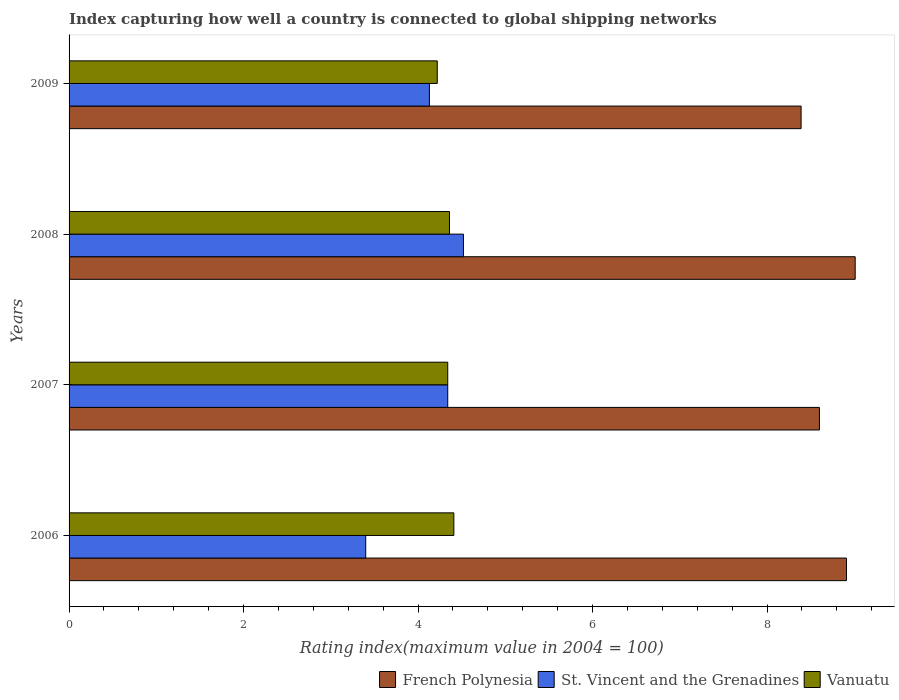How many different coloured bars are there?
Provide a short and direct response. 3. How many groups of bars are there?
Make the answer very short. 4. How many bars are there on the 3rd tick from the top?
Provide a succinct answer. 3. What is the label of the 2nd group of bars from the top?
Ensure brevity in your answer.  2008. What is the rating index in St. Vincent and the Grenadines in 2006?
Your response must be concise. 3.4. Across all years, what is the maximum rating index in St. Vincent and the Grenadines?
Offer a very short reply. 4.52. Across all years, what is the minimum rating index in French Polynesia?
Keep it short and to the point. 8.39. In which year was the rating index in St. Vincent and the Grenadines maximum?
Your response must be concise. 2008. In which year was the rating index in Vanuatu minimum?
Your answer should be very brief. 2009. What is the total rating index in Vanuatu in the graph?
Provide a succinct answer. 17.33. What is the difference between the rating index in Vanuatu in 2007 and that in 2009?
Your response must be concise. 0.12. What is the difference between the rating index in Vanuatu in 2006 and the rating index in St. Vincent and the Grenadines in 2008?
Make the answer very short. -0.11. What is the average rating index in St. Vincent and the Grenadines per year?
Ensure brevity in your answer.  4.1. In the year 2008, what is the difference between the rating index in French Polynesia and rating index in Vanuatu?
Keep it short and to the point. 4.65. In how many years, is the rating index in French Polynesia greater than 6 ?
Your response must be concise. 4. What is the ratio of the rating index in French Polynesia in 2008 to that in 2009?
Offer a terse response. 1.07. Is the difference between the rating index in French Polynesia in 2007 and 2008 greater than the difference between the rating index in Vanuatu in 2007 and 2008?
Provide a succinct answer. No. What is the difference between the highest and the second highest rating index in French Polynesia?
Your response must be concise. 0.1. What is the difference between the highest and the lowest rating index in Vanuatu?
Offer a very short reply. 0.19. What does the 3rd bar from the top in 2006 represents?
Ensure brevity in your answer.  French Polynesia. What does the 1st bar from the bottom in 2007 represents?
Make the answer very short. French Polynesia. Is it the case that in every year, the sum of the rating index in Vanuatu and rating index in St. Vincent and the Grenadines is greater than the rating index in French Polynesia?
Offer a terse response. No. How many bars are there?
Your response must be concise. 12. Are the values on the major ticks of X-axis written in scientific E-notation?
Offer a terse response. No. Does the graph contain any zero values?
Ensure brevity in your answer.  No. Does the graph contain grids?
Ensure brevity in your answer.  No. How are the legend labels stacked?
Your response must be concise. Horizontal. What is the title of the graph?
Your answer should be very brief. Index capturing how well a country is connected to global shipping networks. What is the label or title of the X-axis?
Your response must be concise. Rating index(maximum value in 2004 = 100). What is the Rating index(maximum value in 2004 = 100) of French Polynesia in 2006?
Provide a short and direct response. 8.91. What is the Rating index(maximum value in 2004 = 100) in St. Vincent and the Grenadines in 2006?
Your answer should be compact. 3.4. What is the Rating index(maximum value in 2004 = 100) of Vanuatu in 2006?
Make the answer very short. 4.41. What is the Rating index(maximum value in 2004 = 100) in French Polynesia in 2007?
Your answer should be very brief. 8.6. What is the Rating index(maximum value in 2004 = 100) of St. Vincent and the Grenadines in 2007?
Give a very brief answer. 4.34. What is the Rating index(maximum value in 2004 = 100) of Vanuatu in 2007?
Provide a short and direct response. 4.34. What is the Rating index(maximum value in 2004 = 100) in French Polynesia in 2008?
Your response must be concise. 9.01. What is the Rating index(maximum value in 2004 = 100) of St. Vincent and the Grenadines in 2008?
Provide a succinct answer. 4.52. What is the Rating index(maximum value in 2004 = 100) in Vanuatu in 2008?
Keep it short and to the point. 4.36. What is the Rating index(maximum value in 2004 = 100) in French Polynesia in 2009?
Your answer should be very brief. 8.39. What is the Rating index(maximum value in 2004 = 100) in St. Vincent and the Grenadines in 2009?
Offer a very short reply. 4.13. What is the Rating index(maximum value in 2004 = 100) of Vanuatu in 2009?
Offer a very short reply. 4.22. Across all years, what is the maximum Rating index(maximum value in 2004 = 100) in French Polynesia?
Provide a short and direct response. 9.01. Across all years, what is the maximum Rating index(maximum value in 2004 = 100) in St. Vincent and the Grenadines?
Your answer should be compact. 4.52. Across all years, what is the maximum Rating index(maximum value in 2004 = 100) in Vanuatu?
Your answer should be very brief. 4.41. Across all years, what is the minimum Rating index(maximum value in 2004 = 100) in French Polynesia?
Your response must be concise. 8.39. Across all years, what is the minimum Rating index(maximum value in 2004 = 100) in Vanuatu?
Give a very brief answer. 4.22. What is the total Rating index(maximum value in 2004 = 100) in French Polynesia in the graph?
Provide a succinct answer. 34.91. What is the total Rating index(maximum value in 2004 = 100) of St. Vincent and the Grenadines in the graph?
Offer a very short reply. 16.39. What is the total Rating index(maximum value in 2004 = 100) in Vanuatu in the graph?
Make the answer very short. 17.33. What is the difference between the Rating index(maximum value in 2004 = 100) in French Polynesia in 2006 and that in 2007?
Keep it short and to the point. 0.31. What is the difference between the Rating index(maximum value in 2004 = 100) of St. Vincent and the Grenadines in 2006 and that in 2007?
Keep it short and to the point. -0.94. What is the difference between the Rating index(maximum value in 2004 = 100) of Vanuatu in 2006 and that in 2007?
Provide a short and direct response. 0.07. What is the difference between the Rating index(maximum value in 2004 = 100) of St. Vincent and the Grenadines in 2006 and that in 2008?
Your answer should be very brief. -1.12. What is the difference between the Rating index(maximum value in 2004 = 100) in Vanuatu in 2006 and that in 2008?
Offer a terse response. 0.05. What is the difference between the Rating index(maximum value in 2004 = 100) in French Polynesia in 2006 and that in 2009?
Provide a short and direct response. 0.52. What is the difference between the Rating index(maximum value in 2004 = 100) of St. Vincent and the Grenadines in 2006 and that in 2009?
Make the answer very short. -0.73. What is the difference between the Rating index(maximum value in 2004 = 100) of Vanuatu in 2006 and that in 2009?
Provide a short and direct response. 0.19. What is the difference between the Rating index(maximum value in 2004 = 100) of French Polynesia in 2007 and that in 2008?
Ensure brevity in your answer.  -0.41. What is the difference between the Rating index(maximum value in 2004 = 100) in St. Vincent and the Grenadines in 2007 and that in 2008?
Make the answer very short. -0.18. What is the difference between the Rating index(maximum value in 2004 = 100) of Vanuatu in 2007 and that in 2008?
Your response must be concise. -0.02. What is the difference between the Rating index(maximum value in 2004 = 100) in French Polynesia in 2007 and that in 2009?
Your answer should be very brief. 0.21. What is the difference between the Rating index(maximum value in 2004 = 100) of St. Vincent and the Grenadines in 2007 and that in 2009?
Offer a very short reply. 0.21. What is the difference between the Rating index(maximum value in 2004 = 100) of Vanuatu in 2007 and that in 2009?
Make the answer very short. 0.12. What is the difference between the Rating index(maximum value in 2004 = 100) in French Polynesia in 2008 and that in 2009?
Offer a very short reply. 0.62. What is the difference between the Rating index(maximum value in 2004 = 100) of St. Vincent and the Grenadines in 2008 and that in 2009?
Keep it short and to the point. 0.39. What is the difference between the Rating index(maximum value in 2004 = 100) in Vanuatu in 2008 and that in 2009?
Make the answer very short. 0.14. What is the difference between the Rating index(maximum value in 2004 = 100) of French Polynesia in 2006 and the Rating index(maximum value in 2004 = 100) of St. Vincent and the Grenadines in 2007?
Offer a terse response. 4.57. What is the difference between the Rating index(maximum value in 2004 = 100) of French Polynesia in 2006 and the Rating index(maximum value in 2004 = 100) of Vanuatu in 2007?
Your answer should be very brief. 4.57. What is the difference between the Rating index(maximum value in 2004 = 100) of St. Vincent and the Grenadines in 2006 and the Rating index(maximum value in 2004 = 100) of Vanuatu in 2007?
Offer a terse response. -0.94. What is the difference between the Rating index(maximum value in 2004 = 100) of French Polynesia in 2006 and the Rating index(maximum value in 2004 = 100) of St. Vincent and the Grenadines in 2008?
Provide a short and direct response. 4.39. What is the difference between the Rating index(maximum value in 2004 = 100) in French Polynesia in 2006 and the Rating index(maximum value in 2004 = 100) in Vanuatu in 2008?
Provide a short and direct response. 4.55. What is the difference between the Rating index(maximum value in 2004 = 100) in St. Vincent and the Grenadines in 2006 and the Rating index(maximum value in 2004 = 100) in Vanuatu in 2008?
Your answer should be compact. -0.96. What is the difference between the Rating index(maximum value in 2004 = 100) of French Polynesia in 2006 and the Rating index(maximum value in 2004 = 100) of St. Vincent and the Grenadines in 2009?
Give a very brief answer. 4.78. What is the difference between the Rating index(maximum value in 2004 = 100) in French Polynesia in 2006 and the Rating index(maximum value in 2004 = 100) in Vanuatu in 2009?
Offer a very short reply. 4.69. What is the difference between the Rating index(maximum value in 2004 = 100) of St. Vincent and the Grenadines in 2006 and the Rating index(maximum value in 2004 = 100) of Vanuatu in 2009?
Provide a short and direct response. -0.82. What is the difference between the Rating index(maximum value in 2004 = 100) of French Polynesia in 2007 and the Rating index(maximum value in 2004 = 100) of St. Vincent and the Grenadines in 2008?
Offer a terse response. 4.08. What is the difference between the Rating index(maximum value in 2004 = 100) in French Polynesia in 2007 and the Rating index(maximum value in 2004 = 100) in Vanuatu in 2008?
Your answer should be compact. 4.24. What is the difference between the Rating index(maximum value in 2004 = 100) of St. Vincent and the Grenadines in 2007 and the Rating index(maximum value in 2004 = 100) of Vanuatu in 2008?
Offer a terse response. -0.02. What is the difference between the Rating index(maximum value in 2004 = 100) of French Polynesia in 2007 and the Rating index(maximum value in 2004 = 100) of St. Vincent and the Grenadines in 2009?
Provide a succinct answer. 4.47. What is the difference between the Rating index(maximum value in 2004 = 100) of French Polynesia in 2007 and the Rating index(maximum value in 2004 = 100) of Vanuatu in 2009?
Give a very brief answer. 4.38. What is the difference between the Rating index(maximum value in 2004 = 100) in St. Vincent and the Grenadines in 2007 and the Rating index(maximum value in 2004 = 100) in Vanuatu in 2009?
Give a very brief answer. 0.12. What is the difference between the Rating index(maximum value in 2004 = 100) in French Polynesia in 2008 and the Rating index(maximum value in 2004 = 100) in St. Vincent and the Grenadines in 2009?
Provide a short and direct response. 4.88. What is the difference between the Rating index(maximum value in 2004 = 100) in French Polynesia in 2008 and the Rating index(maximum value in 2004 = 100) in Vanuatu in 2009?
Make the answer very short. 4.79. What is the average Rating index(maximum value in 2004 = 100) of French Polynesia per year?
Your answer should be compact. 8.73. What is the average Rating index(maximum value in 2004 = 100) in St. Vincent and the Grenadines per year?
Offer a very short reply. 4.1. What is the average Rating index(maximum value in 2004 = 100) in Vanuatu per year?
Give a very brief answer. 4.33. In the year 2006, what is the difference between the Rating index(maximum value in 2004 = 100) of French Polynesia and Rating index(maximum value in 2004 = 100) of St. Vincent and the Grenadines?
Your answer should be very brief. 5.51. In the year 2006, what is the difference between the Rating index(maximum value in 2004 = 100) of French Polynesia and Rating index(maximum value in 2004 = 100) of Vanuatu?
Make the answer very short. 4.5. In the year 2006, what is the difference between the Rating index(maximum value in 2004 = 100) of St. Vincent and the Grenadines and Rating index(maximum value in 2004 = 100) of Vanuatu?
Keep it short and to the point. -1.01. In the year 2007, what is the difference between the Rating index(maximum value in 2004 = 100) in French Polynesia and Rating index(maximum value in 2004 = 100) in St. Vincent and the Grenadines?
Provide a short and direct response. 4.26. In the year 2007, what is the difference between the Rating index(maximum value in 2004 = 100) of French Polynesia and Rating index(maximum value in 2004 = 100) of Vanuatu?
Provide a succinct answer. 4.26. In the year 2008, what is the difference between the Rating index(maximum value in 2004 = 100) in French Polynesia and Rating index(maximum value in 2004 = 100) in St. Vincent and the Grenadines?
Ensure brevity in your answer.  4.49. In the year 2008, what is the difference between the Rating index(maximum value in 2004 = 100) in French Polynesia and Rating index(maximum value in 2004 = 100) in Vanuatu?
Ensure brevity in your answer.  4.65. In the year 2008, what is the difference between the Rating index(maximum value in 2004 = 100) of St. Vincent and the Grenadines and Rating index(maximum value in 2004 = 100) of Vanuatu?
Your response must be concise. 0.16. In the year 2009, what is the difference between the Rating index(maximum value in 2004 = 100) of French Polynesia and Rating index(maximum value in 2004 = 100) of St. Vincent and the Grenadines?
Give a very brief answer. 4.26. In the year 2009, what is the difference between the Rating index(maximum value in 2004 = 100) of French Polynesia and Rating index(maximum value in 2004 = 100) of Vanuatu?
Your answer should be very brief. 4.17. In the year 2009, what is the difference between the Rating index(maximum value in 2004 = 100) in St. Vincent and the Grenadines and Rating index(maximum value in 2004 = 100) in Vanuatu?
Make the answer very short. -0.09. What is the ratio of the Rating index(maximum value in 2004 = 100) of French Polynesia in 2006 to that in 2007?
Provide a short and direct response. 1.04. What is the ratio of the Rating index(maximum value in 2004 = 100) in St. Vincent and the Grenadines in 2006 to that in 2007?
Your response must be concise. 0.78. What is the ratio of the Rating index(maximum value in 2004 = 100) of Vanuatu in 2006 to that in 2007?
Ensure brevity in your answer.  1.02. What is the ratio of the Rating index(maximum value in 2004 = 100) of French Polynesia in 2006 to that in 2008?
Your answer should be compact. 0.99. What is the ratio of the Rating index(maximum value in 2004 = 100) in St. Vincent and the Grenadines in 2006 to that in 2008?
Your answer should be compact. 0.75. What is the ratio of the Rating index(maximum value in 2004 = 100) of Vanuatu in 2006 to that in 2008?
Your answer should be very brief. 1.01. What is the ratio of the Rating index(maximum value in 2004 = 100) in French Polynesia in 2006 to that in 2009?
Provide a succinct answer. 1.06. What is the ratio of the Rating index(maximum value in 2004 = 100) in St. Vincent and the Grenadines in 2006 to that in 2009?
Provide a short and direct response. 0.82. What is the ratio of the Rating index(maximum value in 2004 = 100) of Vanuatu in 2006 to that in 2009?
Provide a short and direct response. 1.04. What is the ratio of the Rating index(maximum value in 2004 = 100) in French Polynesia in 2007 to that in 2008?
Make the answer very short. 0.95. What is the ratio of the Rating index(maximum value in 2004 = 100) in St. Vincent and the Grenadines in 2007 to that in 2008?
Offer a terse response. 0.96. What is the ratio of the Rating index(maximum value in 2004 = 100) in Vanuatu in 2007 to that in 2008?
Ensure brevity in your answer.  1. What is the ratio of the Rating index(maximum value in 2004 = 100) in St. Vincent and the Grenadines in 2007 to that in 2009?
Your answer should be very brief. 1.05. What is the ratio of the Rating index(maximum value in 2004 = 100) of Vanuatu in 2007 to that in 2009?
Provide a succinct answer. 1.03. What is the ratio of the Rating index(maximum value in 2004 = 100) in French Polynesia in 2008 to that in 2009?
Give a very brief answer. 1.07. What is the ratio of the Rating index(maximum value in 2004 = 100) of St. Vincent and the Grenadines in 2008 to that in 2009?
Your answer should be very brief. 1.09. What is the ratio of the Rating index(maximum value in 2004 = 100) in Vanuatu in 2008 to that in 2009?
Offer a terse response. 1.03. What is the difference between the highest and the second highest Rating index(maximum value in 2004 = 100) in St. Vincent and the Grenadines?
Your response must be concise. 0.18. What is the difference between the highest and the lowest Rating index(maximum value in 2004 = 100) of French Polynesia?
Provide a short and direct response. 0.62. What is the difference between the highest and the lowest Rating index(maximum value in 2004 = 100) of St. Vincent and the Grenadines?
Offer a very short reply. 1.12. What is the difference between the highest and the lowest Rating index(maximum value in 2004 = 100) in Vanuatu?
Your answer should be very brief. 0.19. 